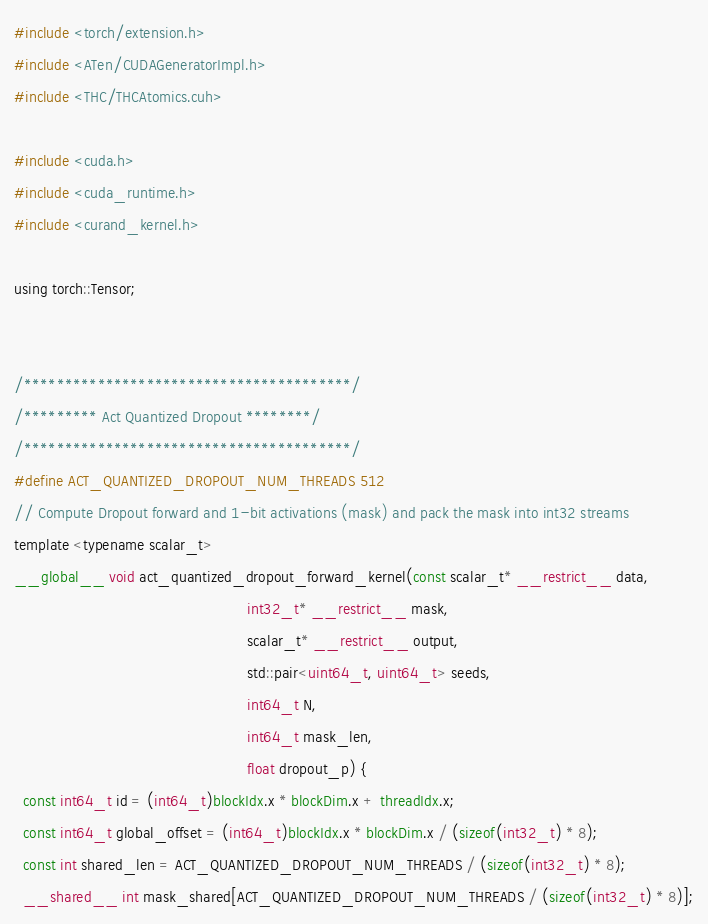Convert code to text. <code><loc_0><loc_0><loc_500><loc_500><_Cuda_>#include <torch/extension.h>
#include <ATen/CUDAGeneratorImpl.h>
#include <THC/THCAtomics.cuh>

#include <cuda.h>
#include <cuda_runtime.h>
#include <curand_kernel.h>

using torch::Tensor;


/****************************************/
/********* Act Quantized Dropout ********/
/****************************************/
#define ACT_QUANTIZED_DROPOUT_NUM_THREADS 512
// Compute Dropout forward and 1-bit activations (mask) and pack the mask into int32 streams
template <typename scalar_t>
__global__ void act_quantized_dropout_forward_kernel(const scalar_t* __restrict__ data,
                                                     int32_t* __restrict__ mask,
                                                     scalar_t* __restrict__ output,
                                                     std::pair<uint64_t, uint64_t> seeds,
                                                     int64_t N,
                                                     int64_t mask_len,
                                                     float dropout_p) {
  const int64_t id = (int64_t)blockIdx.x * blockDim.x + threadIdx.x;
  const int64_t global_offset = (int64_t)blockIdx.x * blockDim.x / (sizeof(int32_t) * 8);
  const int shared_len = ACT_QUANTIZED_DROPOUT_NUM_THREADS / (sizeof(int32_t) * 8);
  __shared__ int mask_shared[ACT_QUANTIZED_DROPOUT_NUM_THREADS / (sizeof(int32_t) * 8)];
</code> 